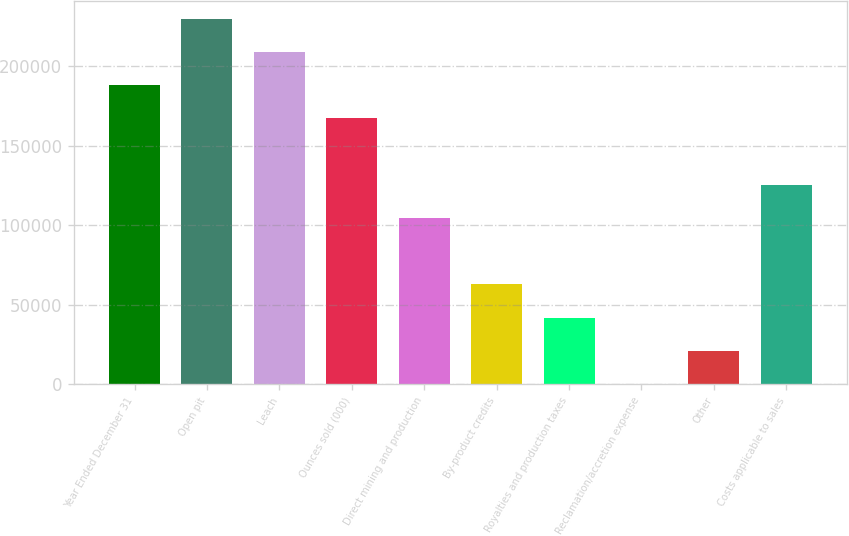Convert chart. <chart><loc_0><loc_0><loc_500><loc_500><bar_chart><fcel>Year Ended December 31<fcel>Open pit<fcel>Leach<fcel>Ounces sold (000)<fcel>Direct mining and production<fcel>By-product credits<fcel>Royalties and production taxes<fcel>Reclamation/accretion expense<fcel>Other<fcel>Costs applicable to sales<nl><fcel>187984<fcel>229758<fcel>208871<fcel>167098<fcel>104438<fcel>62665.5<fcel>41779<fcel>6<fcel>20892.5<fcel>125325<nl></chart> 